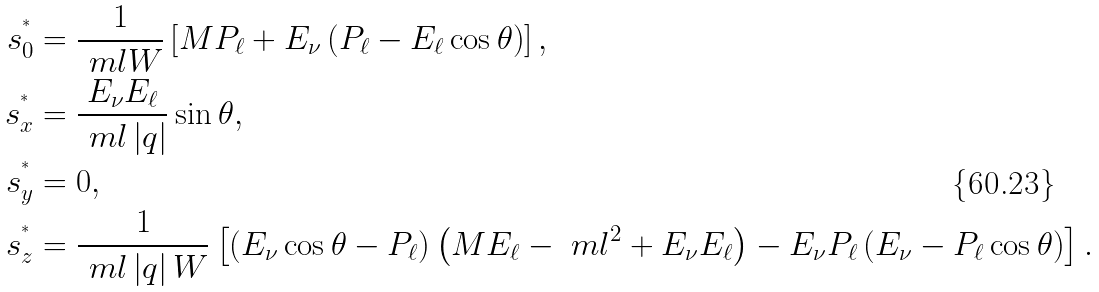<formula> <loc_0><loc_0><loc_500><loc_500>s _ { 0 } ^ { ^ { * } } & = \frac { 1 } { \ m l W } \left [ M P _ { \ell } + E _ { \nu } \left ( P _ { \ell } - E _ { \ell } \cos \theta \right ) \right ] , \\ s _ { x } ^ { ^ { * } } & = \frac { E _ { \nu } E _ { \ell } } { \ m l \left | q \right | } \sin \theta , \\ s _ { y } ^ { ^ { * } } & = 0 , \\ s _ { z } ^ { ^ { * } } & = \frac { 1 } { \ m l \left | q \right | W } \left [ \left ( E _ { \nu } \cos \theta - P _ { \ell } \right ) \left ( M E _ { \ell } - \ m l ^ { 2 } + E _ { \nu } E _ { \ell } \right ) - E _ { \nu } P _ { \ell } \left ( E _ { \nu } - P _ { \ell } \cos \theta \right ) \right ] .</formula> 